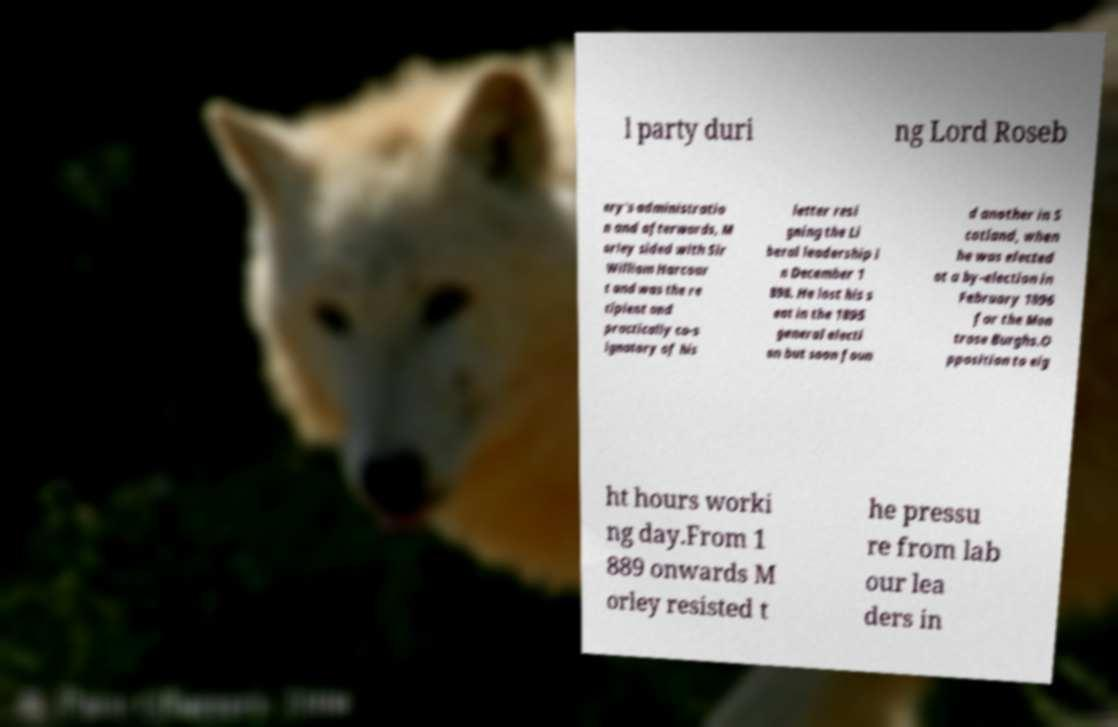There's text embedded in this image that I need extracted. Can you transcribe it verbatim? l party duri ng Lord Roseb ery's administratio n and afterwards, M orley sided with Sir William Harcour t and was the re cipient and practically co-s ignatory of his letter resi gning the Li beral leadership i n December 1 898. He lost his s eat in the 1895 general electi on but soon foun d another in S cotland, when he was elected at a by-election in February 1896 for the Mon trose Burghs.O pposition to eig ht hours worki ng day.From 1 889 onwards M orley resisted t he pressu re from lab our lea ders in 